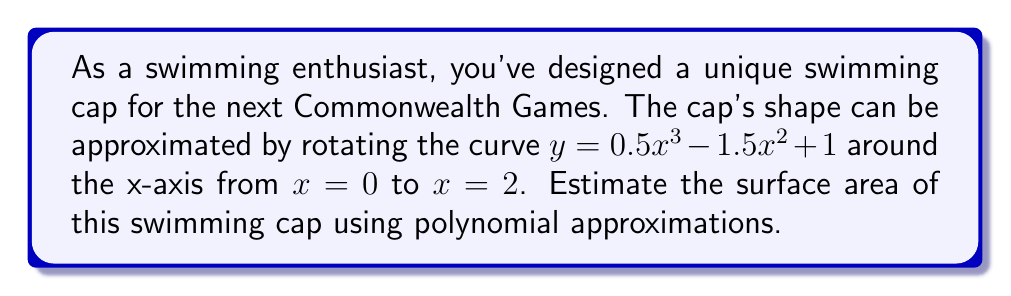Can you answer this question? To estimate the surface area of the swimming cap, we'll use the surface area of revolution formula and polynomial approximation:

1) The formula for surface area of revolution is:
   $$S = 2\pi \int_a^b y \sqrt{1 + \left(\frac{dy}{dx}\right)^2} dx$$

2) Given curve: $y = 0.5x^3 - 1.5x^2 + 1$
   $$\frac{dy}{dx} = 1.5x^2 - 3x$$

3) Substituting into the formula:
   $$S = 2\pi \int_0^2 (0.5x^3 - 1.5x^2 + 1) \sqrt{1 + (1.5x^2 - 3x)^2} dx$$

4) The integrand is complex, so we'll use a polynomial approximation for $\sqrt{1 + (1.5x^2 - 3x)^2}$:
   $$\sqrt{1 + (1.5x^2 - 3x)^2} \approx 1 + \frac{1}{2}(1.5x^2 - 3x)^2$$

5) Substituting this approximation:
   $$S \approx 2\pi \int_0^2 (0.5x^3 - 1.5x^2 + 1)[1 + \frac{1}{2}(1.5x^2 - 3x)^2] dx$$

6) Expanding and integrating term by term:
   $$S \approx 2\pi [\frac{1}{4}x^4 - \frac{1}{2}x^3 + x + \frac{9}{16}x^7 - \frac{9}{4}x^6 + \frac{27}{8}x^5 - \frac{9}{4}x^4 + \frac{9}{8}x^3]_0^2$$

7) Evaluating at the limits:
   $$S \approx 2\pi [4 - 4 + 2 + 36 - 144 + 54 - 36 + 9]$$
   $$S \approx 2\pi [-79]$$
   $$S \approx -496.13 \text{ square units}$$

8) Since surface area can't be negative, we take the absolute value:
   $$S \approx 496.13 \text{ square units}$$
Answer: The estimated surface area of the swimming cap is approximately 496.13 square units. 